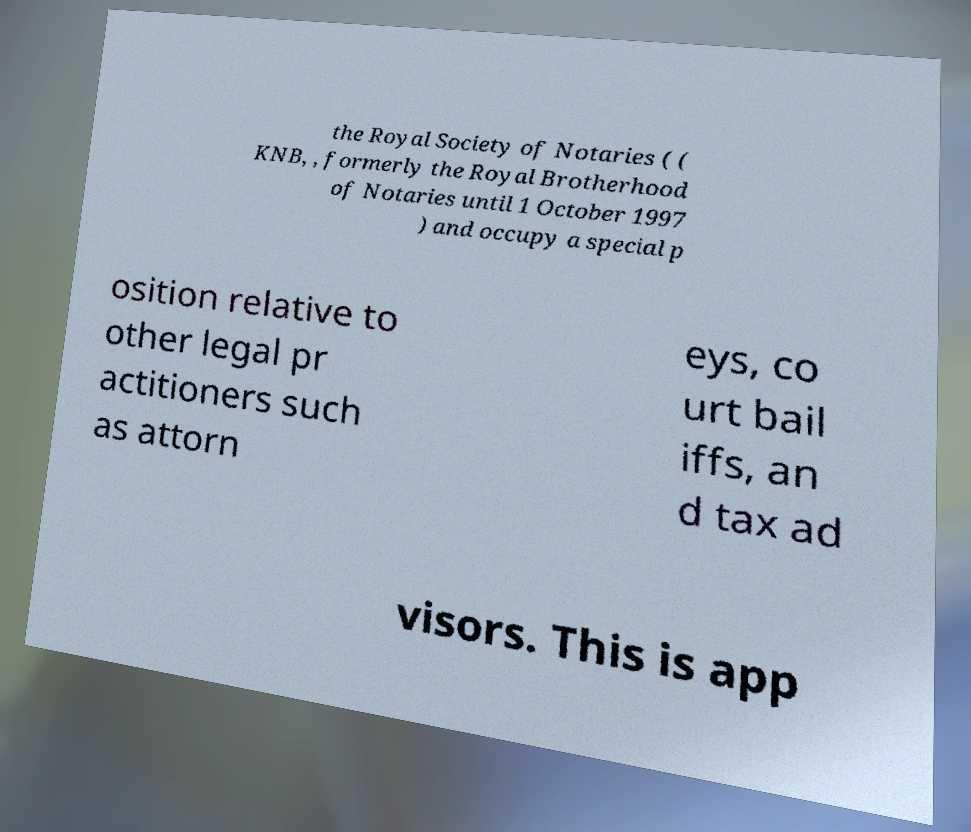Could you assist in decoding the text presented in this image and type it out clearly? the Royal Society of Notaries ( ( KNB, , formerly the Royal Brotherhood of Notaries until 1 October 1997 ) and occupy a special p osition relative to other legal pr actitioners such as attorn eys, co urt bail iffs, an d tax ad visors. This is app 